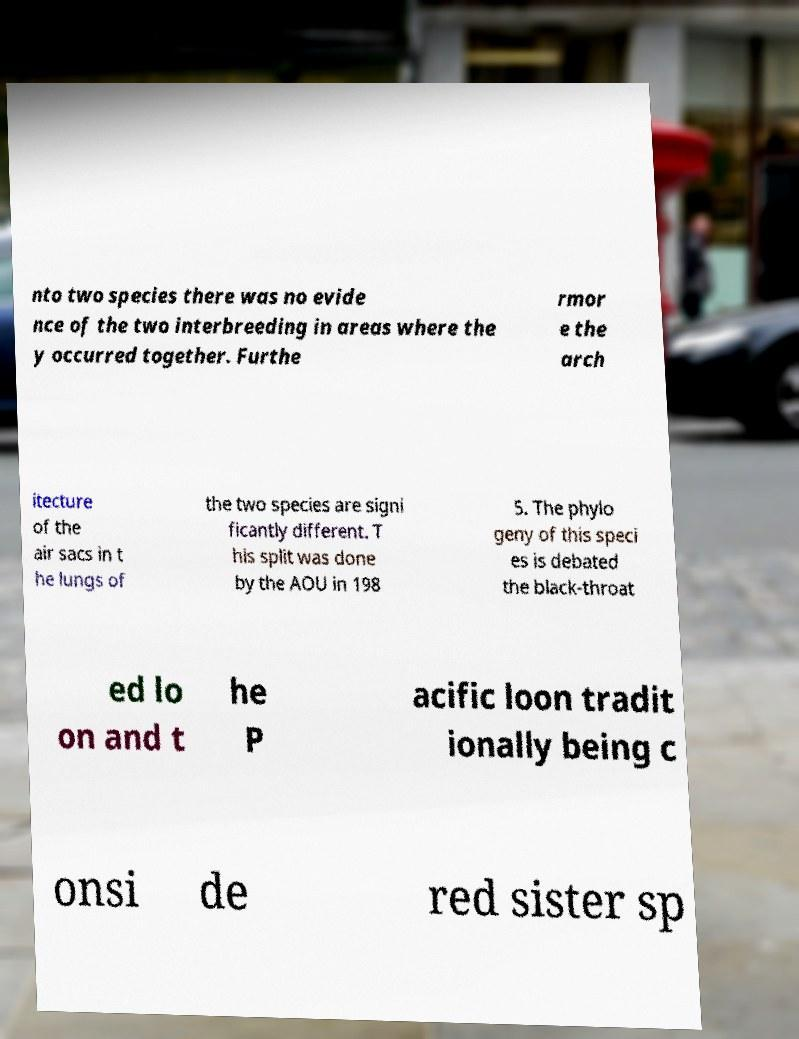Please read and relay the text visible in this image. What does it say? nto two species there was no evide nce of the two interbreeding in areas where the y occurred together. Furthe rmor e the arch itecture of the air sacs in t he lungs of the two species are signi ficantly different. T his split was done by the AOU in 198 5. The phylo geny of this speci es is debated the black-throat ed lo on and t he P acific loon tradit ionally being c onsi de red sister sp 